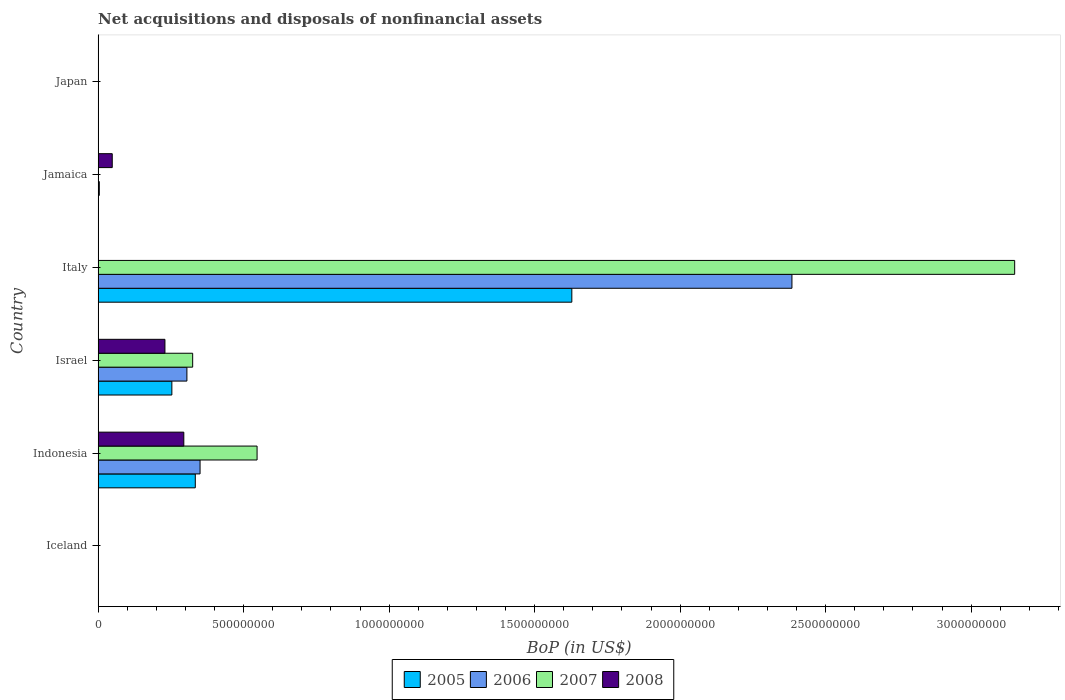How many bars are there on the 3rd tick from the top?
Your answer should be very brief. 3. How many bars are there on the 3rd tick from the bottom?
Offer a terse response. 4. What is the label of the 2nd group of bars from the top?
Your answer should be compact. Jamaica. What is the Balance of Payments in 2006 in Jamaica?
Keep it short and to the point. 4.09e+06. Across all countries, what is the maximum Balance of Payments in 2005?
Ensure brevity in your answer.  1.63e+09. Across all countries, what is the minimum Balance of Payments in 2005?
Offer a very short reply. 0. What is the total Balance of Payments in 2006 in the graph?
Give a very brief answer. 3.04e+09. What is the difference between the Balance of Payments in 2008 in Indonesia and that in Israel?
Offer a terse response. 6.49e+07. What is the difference between the Balance of Payments in 2005 in Japan and the Balance of Payments in 2006 in Jamaica?
Give a very brief answer. -4.09e+06. What is the average Balance of Payments in 2005 per country?
Keep it short and to the point. 3.69e+08. What is the difference between the Balance of Payments in 2006 and Balance of Payments in 2007 in Italy?
Keep it short and to the point. -7.65e+08. Is the Balance of Payments in 2005 in Indonesia less than that in Italy?
Your response must be concise. Yes. What is the difference between the highest and the second highest Balance of Payments in 2008?
Give a very brief answer. 6.49e+07. What is the difference between the highest and the lowest Balance of Payments in 2007?
Ensure brevity in your answer.  3.15e+09. Is the sum of the Balance of Payments in 2005 in Israel and Italy greater than the maximum Balance of Payments in 2008 across all countries?
Keep it short and to the point. Yes. Are all the bars in the graph horizontal?
Your answer should be compact. Yes. Are the values on the major ticks of X-axis written in scientific E-notation?
Ensure brevity in your answer.  No. Where does the legend appear in the graph?
Provide a short and direct response. Bottom center. What is the title of the graph?
Give a very brief answer. Net acquisitions and disposals of nonfinancial assets. Does "1971" appear as one of the legend labels in the graph?
Provide a succinct answer. No. What is the label or title of the X-axis?
Your answer should be very brief. BoP (in US$). What is the label or title of the Y-axis?
Offer a very short reply. Country. What is the BoP (in US$) in 2006 in Iceland?
Your answer should be very brief. 0. What is the BoP (in US$) of 2007 in Iceland?
Provide a short and direct response. 0. What is the BoP (in US$) of 2005 in Indonesia?
Offer a very short reply. 3.34e+08. What is the BoP (in US$) of 2006 in Indonesia?
Your answer should be very brief. 3.50e+08. What is the BoP (in US$) of 2007 in Indonesia?
Give a very brief answer. 5.46e+08. What is the BoP (in US$) in 2008 in Indonesia?
Provide a succinct answer. 2.94e+08. What is the BoP (in US$) of 2005 in Israel?
Ensure brevity in your answer.  2.53e+08. What is the BoP (in US$) of 2006 in Israel?
Make the answer very short. 3.05e+08. What is the BoP (in US$) in 2007 in Israel?
Ensure brevity in your answer.  3.25e+08. What is the BoP (in US$) in 2008 in Israel?
Keep it short and to the point. 2.30e+08. What is the BoP (in US$) of 2005 in Italy?
Ensure brevity in your answer.  1.63e+09. What is the BoP (in US$) of 2006 in Italy?
Provide a succinct answer. 2.38e+09. What is the BoP (in US$) in 2007 in Italy?
Give a very brief answer. 3.15e+09. What is the BoP (in US$) of 2006 in Jamaica?
Your answer should be very brief. 4.09e+06. What is the BoP (in US$) in 2007 in Jamaica?
Offer a terse response. 6.90e+05. What is the BoP (in US$) of 2008 in Jamaica?
Provide a short and direct response. 4.86e+07. What is the BoP (in US$) of 2006 in Japan?
Keep it short and to the point. 0. What is the BoP (in US$) in 2008 in Japan?
Give a very brief answer. 0. Across all countries, what is the maximum BoP (in US$) in 2005?
Make the answer very short. 1.63e+09. Across all countries, what is the maximum BoP (in US$) in 2006?
Your answer should be very brief. 2.38e+09. Across all countries, what is the maximum BoP (in US$) of 2007?
Your answer should be very brief. 3.15e+09. Across all countries, what is the maximum BoP (in US$) in 2008?
Your answer should be very brief. 2.94e+08. Across all countries, what is the minimum BoP (in US$) in 2005?
Ensure brevity in your answer.  0. Across all countries, what is the minimum BoP (in US$) of 2007?
Keep it short and to the point. 0. What is the total BoP (in US$) of 2005 in the graph?
Your answer should be compact. 2.22e+09. What is the total BoP (in US$) of 2006 in the graph?
Give a very brief answer. 3.04e+09. What is the total BoP (in US$) of 2007 in the graph?
Your response must be concise. 4.02e+09. What is the total BoP (in US$) of 2008 in the graph?
Make the answer very short. 5.73e+08. What is the difference between the BoP (in US$) of 2005 in Indonesia and that in Israel?
Keep it short and to the point. 8.05e+07. What is the difference between the BoP (in US$) in 2006 in Indonesia and that in Israel?
Your answer should be compact. 4.52e+07. What is the difference between the BoP (in US$) of 2007 in Indonesia and that in Israel?
Keep it short and to the point. 2.21e+08. What is the difference between the BoP (in US$) of 2008 in Indonesia and that in Israel?
Keep it short and to the point. 6.49e+07. What is the difference between the BoP (in US$) in 2005 in Indonesia and that in Italy?
Give a very brief answer. -1.29e+09. What is the difference between the BoP (in US$) of 2006 in Indonesia and that in Italy?
Give a very brief answer. -2.03e+09. What is the difference between the BoP (in US$) in 2007 in Indonesia and that in Italy?
Your answer should be very brief. -2.60e+09. What is the difference between the BoP (in US$) of 2005 in Indonesia and that in Jamaica?
Offer a very short reply. 3.34e+08. What is the difference between the BoP (in US$) of 2006 in Indonesia and that in Jamaica?
Give a very brief answer. 3.46e+08. What is the difference between the BoP (in US$) in 2007 in Indonesia and that in Jamaica?
Keep it short and to the point. 5.46e+08. What is the difference between the BoP (in US$) of 2008 in Indonesia and that in Jamaica?
Ensure brevity in your answer.  2.46e+08. What is the difference between the BoP (in US$) of 2005 in Israel and that in Italy?
Offer a terse response. -1.37e+09. What is the difference between the BoP (in US$) of 2006 in Israel and that in Italy?
Keep it short and to the point. -2.08e+09. What is the difference between the BoP (in US$) of 2007 in Israel and that in Italy?
Provide a short and direct response. -2.82e+09. What is the difference between the BoP (in US$) of 2005 in Israel and that in Jamaica?
Your answer should be very brief. 2.53e+08. What is the difference between the BoP (in US$) in 2006 in Israel and that in Jamaica?
Your response must be concise. 3.01e+08. What is the difference between the BoP (in US$) in 2007 in Israel and that in Jamaica?
Give a very brief answer. 3.24e+08. What is the difference between the BoP (in US$) of 2008 in Israel and that in Jamaica?
Keep it short and to the point. 1.81e+08. What is the difference between the BoP (in US$) of 2005 in Italy and that in Jamaica?
Make the answer very short. 1.63e+09. What is the difference between the BoP (in US$) in 2006 in Italy and that in Jamaica?
Your answer should be compact. 2.38e+09. What is the difference between the BoP (in US$) in 2007 in Italy and that in Jamaica?
Make the answer very short. 3.15e+09. What is the difference between the BoP (in US$) in 2005 in Indonesia and the BoP (in US$) in 2006 in Israel?
Make the answer very short. 2.88e+07. What is the difference between the BoP (in US$) of 2005 in Indonesia and the BoP (in US$) of 2007 in Israel?
Give a very brief answer. 9.02e+06. What is the difference between the BoP (in US$) of 2005 in Indonesia and the BoP (in US$) of 2008 in Israel?
Keep it short and to the point. 1.04e+08. What is the difference between the BoP (in US$) in 2006 in Indonesia and the BoP (in US$) in 2007 in Israel?
Ensure brevity in your answer.  2.54e+07. What is the difference between the BoP (in US$) of 2006 in Indonesia and the BoP (in US$) of 2008 in Israel?
Provide a short and direct response. 1.21e+08. What is the difference between the BoP (in US$) in 2007 in Indonesia and the BoP (in US$) in 2008 in Israel?
Your answer should be compact. 3.17e+08. What is the difference between the BoP (in US$) in 2005 in Indonesia and the BoP (in US$) in 2006 in Italy?
Your answer should be compact. -2.05e+09. What is the difference between the BoP (in US$) in 2005 in Indonesia and the BoP (in US$) in 2007 in Italy?
Ensure brevity in your answer.  -2.82e+09. What is the difference between the BoP (in US$) of 2006 in Indonesia and the BoP (in US$) of 2007 in Italy?
Your answer should be very brief. -2.80e+09. What is the difference between the BoP (in US$) of 2005 in Indonesia and the BoP (in US$) of 2006 in Jamaica?
Your answer should be compact. 3.30e+08. What is the difference between the BoP (in US$) of 2005 in Indonesia and the BoP (in US$) of 2007 in Jamaica?
Make the answer very short. 3.33e+08. What is the difference between the BoP (in US$) of 2005 in Indonesia and the BoP (in US$) of 2008 in Jamaica?
Your response must be concise. 2.85e+08. What is the difference between the BoP (in US$) of 2006 in Indonesia and the BoP (in US$) of 2007 in Jamaica?
Give a very brief answer. 3.50e+08. What is the difference between the BoP (in US$) of 2006 in Indonesia and the BoP (in US$) of 2008 in Jamaica?
Make the answer very short. 3.02e+08. What is the difference between the BoP (in US$) in 2007 in Indonesia and the BoP (in US$) in 2008 in Jamaica?
Provide a succinct answer. 4.98e+08. What is the difference between the BoP (in US$) in 2005 in Israel and the BoP (in US$) in 2006 in Italy?
Your answer should be compact. -2.13e+09. What is the difference between the BoP (in US$) of 2005 in Israel and the BoP (in US$) of 2007 in Italy?
Offer a very short reply. -2.90e+09. What is the difference between the BoP (in US$) of 2006 in Israel and the BoP (in US$) of 2007 in Italy?
Provide a succinct answer. -2.84e+09. What is the difference between the BoP (in US$) in 2005 in Israel and the BoP (in US$) in 2006 in Jamaica?
Your response must be concise. 2.49e+08. What is the difference between the BoP (in US$) of 2005 in Israel and the BoP (in US$) of 2007 in Jamaica?
Provide a short and direct response. 2.53e+08. What is the difference between the BoP (in US$) of 2005 in Israel and the BoP (in US$) of 2008 in Jamaica?
Keep it short and to the point. 2.05e+08. What is the difference between the BoP (in US$) in 2006 in Israel and the BoP (in US$) in 2007 in Jamaica?
Provide a succinct answer. 3.04e+08. What is the difference between the BoP (in US$) of 2006 in Israel and the BoP (in US$) of 2008 in Jamaica?
Keep it short and to the point. 2.57e+08. What is the difference between the BoP (in US$) in 2007 in Israel and the BoP (in US$) in 2008 in Jamaica?
Your answer should be compact. 2.76e+08. What is the difference between the BoP (in US$) in 2005 in Italy and the BoP (in US$) in 2006 in Jamaica?
Ensure brevity in your answer.  1.62e+09. What is the difference between the BoP (in US$) of 2005 in Italy and the BoP (in US$) of 2007 in Jamaica?
Ensure brevity in your answer.  1.63e+09. What is the difference between the BoP (in US$) in 2005 in Italy and the BoP (in US$) in 2008 in Jamaica?
Provide a succinct answer. 1.58e+09. What is the difference between the BoP (in US$) of 2006 in Italy and the BoP (in US$) of 2007 in Jamaica?
Provide a succinct answer. 2.38e+09. What is the difference between the BoP (in US$) in 2006 in Italy and the BoP (in US$) in 2008 in Jamaica?
Your answer should be very brief. 2.34e+09. What is the difference between the BoP (in US$) of 2007 in Italy and the BoP (in US$) of 2008 in Jamaica?
Your answer should be very brief. 3.10e+09. What is the average BoP (in US$) of 2005 per country?
Offer a very short reply. 3.69e+08. What is the average BoP (in US$) of 2006 per country?
Ensure brevity in your answer.  5.07e+08. What is the average BoP (in US$) of 2007 per country?
Provide a succinct answer. 6.70e+08. What is the average BoP (in US$) of 2008 per country?
Offer a very short reply. 9.54e+07. What is the difference between the BoP (in US$) of 2005 and BoP (in US$) of 2006 in Indonesia?
Your response must be concise. -1.64e+07. What is the difference between the BoP (in US$) of 2005 and BoP (in US$) of 2007 in Indonesia?
Keep it short and to the point. -2.12e+08. What is the difference between the BoP (in US$) in 2005 and BoP (in US$) in 2008 in Indonesia?
Your answer should be compact. 3.95e+07. What is the difference between the BoP (in US$) in 2006 and BoP (in US$) in 2007 in Indonesia?
Give a very brief answer. -1.96e+08. What is the difference between the BoP (in US$) of 2006 and BoP (in US$) of 2008 in Indonesia?
Your response must be concise. 5.59e+07. What is the difference between the BoP (in US$) of 2007 and BoP (in US$) of 2008 in Indonesia?
Make the answer very short. 2.52e+08. What is the difference between the BoP (in US$) in 2005 and BoP (in US$) in 2006 in Israel?
Provide a succinct answer. -5.17e+07. What is the difference between the BoP (in US$) in 2005 and BoP (in US$) in 2007 in Israel?
Your response must be concise. -7.15e+07. What is the difference between the BoP (in US$) in 2005 and BoP (in US$) in 2008 in Israel?
Offer a very short reply. 2.38e+07. What is the difference between the BoP (in US$) in 2006 and BoP (in US$) in 2007 in Israel?
Keep it short and to the point. -1.98e+07. What is the difference between the BoP (in US$) of 2006 and BoP (in US$) of 2008 in Israel?
Your response must be concise. 7.55e+07. What is the difference between the BoP (in US$) of 2007 and BoP (in US$) of 2008 in Israel?
Make the answer very short. 9.53e+07. What is the difference between the BoP (in US$) of 2005 and BoP (in US$) of 2006 in Italy?
Ensure brevity in your answer.  -7.56e+08. What is the difference between the BoP (in US$) in 2005 and BoP (in US$) in 2007 in Italy?
Your answer should be compact. -1.52e+09. What is the difference between the BoP (in US$) of 2006 and BoP (in US$) of 2007 in Italy?
Keep it short and to the point. -7.65e+08. What is the difference between the BoP (in US$) of 2005 and BoP (in US$) of 2006 in Jamaica?
Provide a short and direct response. -3.79e+06. What is the difference between the BoP (in US$) of 2005 and BoP (in US$) of 2007 in Jamaica?
Offer a very short reply. -3.90e+05. What is the difference between the BoP (in US$) of 2005 and BoP (in US$) of 2008 in Jamaica?
Your response must be concise. -4.83e+07. What is the difference between the BoP (in US$) in 2006 and BoP (in US$) in 2007 in Jamaica?
Keep it short and to the point. 3.40e+06. What is the difference between the BoP (in US$) of 2006 and BoP (in US$) of 2008 in Jamaica?
Ensure brevity in your answer.  -4.45e+07. What is the difference between the BoP (in US$) in 2007 and BoP (in US$) in 2008 in Jamaica?
Provide a short and direct response. -4.79e+07. What is the ratio of the BoP (in US$) of 2005 in Indonesia to that in Israel?
Make the answer very short. 1.32. What is the ratio of the BoP (in US$) in 2006 in Indonesia to that in Israel?
Your answer should be very brief. 1.15. What is the ratio of the BoP (in US$) of 2007 in Indonesia to that in Israel?
Ensure brevity in your answer.  1.68. What is the ratio of the BoP (in US$) of 2008 in Indonesia to that in Israel?
Your answer should be compact. 1.28. What is the ratio of the BoP (in US$) of 2005 in Indonesia to that in Italy?
Your answer should be compact. 0.21. What is the ratio of the BoP (in US$) in 2006 in Indonesia to that in Italy?
Give a very brief answer. 0.15. What is the ratio of the BoP (in US$) of 2007 in Indonesia to that in Italy?
Offer a terse response. 0.17. What is the ratio of the BoP (in US$) in 2005 in Indonesia to that in Jamaica?
Provide a succinct answer. 1113.06. What is the ratio of the BoP (in US$) of 2006 in Indonesia to that in Jamaica?
Offer a terse response. 85.65. What is the ratio of the BoP (in US$) in 2007 in Indonesia to that in Jamaica?
Ensure brevity in your answer.  791.59. What is the ratio of the BoP (in US$) in 2008 in Indonesia to that in Jamaica?
Offer a terse response. 6.06. What is the ratio of the BoP (in US$) of 2005 in Israel to that in Italy?
Ensure brevity in your answer.  0.16. What is the ratio of the BoP (in US$) in 2006 in Israel to that in Italy?
Your response must be concise. 0.13. What is the ratio of the BoP (in US$) in 2007 in Israel to that in Italy?
Make the answer very short. 0.1. What is the ratio of the BoP (in US$) of 2005 in Israel to that in Jamaica?
Keep it short and to the point. 844.67. What is the ratio of the BoP (in US$) of 2006 in Israel to that in Jamaica?
Offer a very short reply. 74.6. What is the ratio of the BoP (in US$) in 2007 in Israel to that in Jamaica?
Your answer should be very brief. 470.87. What is the ratio of the BoP (in US$) in 2008 in Israel to that in Jamaica?
Keep it short and to the point. 4.73. What is the ratio of the BoP (in US$) of 2005 in Italy to that in Jamaica?
Give a very brief answer. 5425.92. What is the ratio of the BoP (in US$) in 2006 in Italy to that in Jamaica?
Offer a terse response. 582.91. What is the ratio of the BoP (in US$) in 2007 in Italy to that in Jamaica?
Offer a very short reply. 4564.42. What is the difference between the highest and the second highest BoP (in US$) of 2005?
Give a very brief answer. 1.29e+09. What is the difference between the highest and the second highest BoP (in US$) in 2006?
Offer a very short reply. 2.03e+09. What is the difference between the highest and the second highest BoP (in US$) in 2007?
Provide a succinct answer. 2.60e+09. What is the difference between the highest and the second highest BoP (in US$) of 2008?
Provide a short and direct response. 6.49e+07. What is the difference between the highest and the lowest BoP (in US$) of 2005?
Give a very brief answer. 1.63e+09. What is the difference between the highest and the lowest BoP (in US$) in 2006?
Your answer should be very brief. 2.38e+09. What is the difference between the highest and the lowest BoP (in US$) of 2007?
Your answer should be very brief. 3.15e+09. What is the difference between the highest and the lowest BoP (in US$) in 2008?
Your answer should be compact. 2.94e+08. 